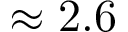Convert formula to latex. <formula><loc_0><loc_0><loc_500><loc_500>\approx 2 . 6</formula> 